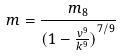Convert formula to latex. <formula><loc_0><loc_0><loc_500><loc_500>m = \frac { m _ { 8 } } { ( { 1 - \frac { v ^ { 9 } } { k ^ { 9 } } ) } ^ { 7 / 9 } }</formula> 